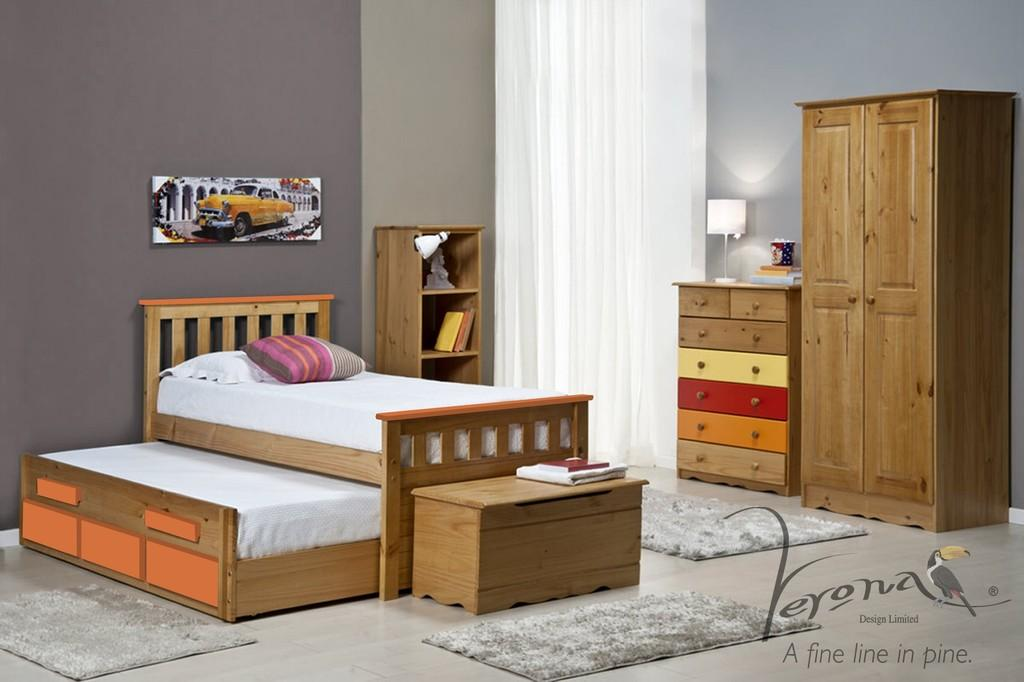What is the main object in the center of the image? There is a bed in the center of the image. What is covering the bed? There is a blanket on the bed. How many pillows are on the bed? There are two pillows on the bed. What type of flooring is around the bed? There is a carpet around the bed. What can be seen in the background of the image? There is a wall, a shelf, a cupboard, a lamp, and a curtain in the background of the image. Where is the toothpaste located in the image? There is no toothpaste present in the image. What type of cap is being worn by the person in the image? There is no person or cap visible in the image. 